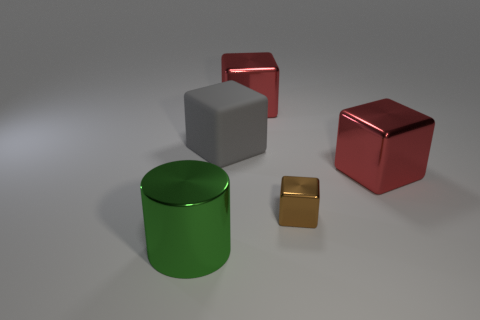Subtract 1 blocks. How many blocks are left? 3 Add 3 gray rubber things. How many objects exist? 8 Subtract all cubes. How many objects are left? 1 Add 2 big blocks. How many big blocks are left? 5 Add 5 big brown matte cubes. How many big brown matte cubes exist? 5 Subtract 0 cyan cylinders. How many objects are left? 5 Subtract all large red cubes. Subtract all big metal cubes. How many objects are left? 1 